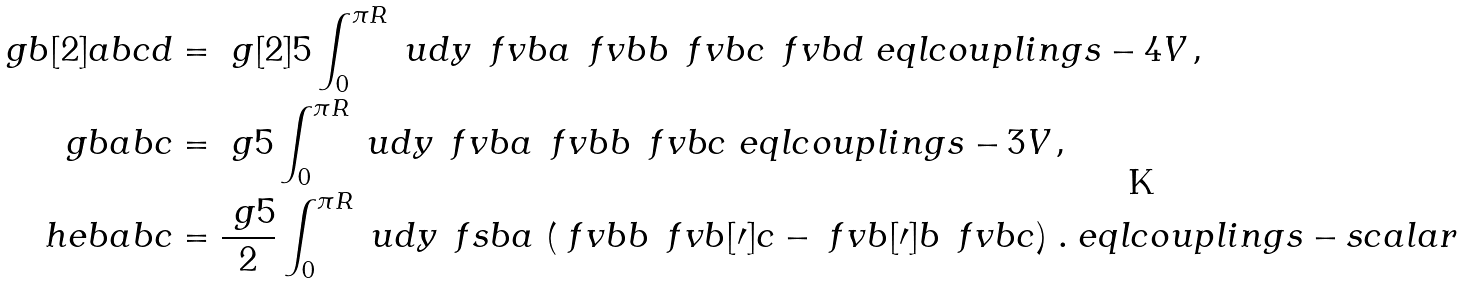<formula> <loc_0><loc_0><loc_500><loc_500>\ g b [ 2 ] { a b c d } & = \ g [ 2 ] { 5 } \int _ { 0 } ^ { \pi R } \ u d y \, \ f v b { a } \, \ f v b { b } \, \ f v b { c } \, \ f v b { d } \ e q l { c o u p l i n g s - 4 V } \, \text {,} \\ \ g b { a b c } & = \ g { 5 } \int _ { 0 } ^ { \pi R } \ u d y \, \ f v b { a } \, \ f v b { b } \, \ f v b { c } \ e q l { c o u p l i n g s - 3 V } \, \text {,} \\ \ h e b { a b c } & = \frac { \ g { 5 } } { 2 } \int _ { 0 } ^ { \pi R } \ u d y \, \ f s b { a } \, \left ( \ f v b { b } \, \ f v b [ \prime ] { c } - \ f v b [ \prime ] { b } \, \ f v b { c } \right ) \, \text {.} \ e q l { c o u p l i n g s - s c a l a r }</formula> 